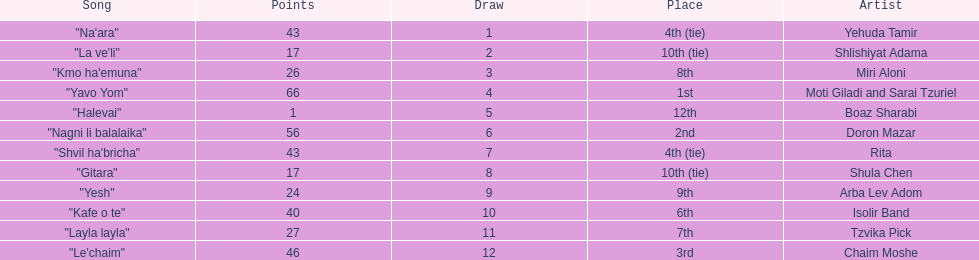Did the song "gitara" or "yesh" earn more points? "Yesh". 